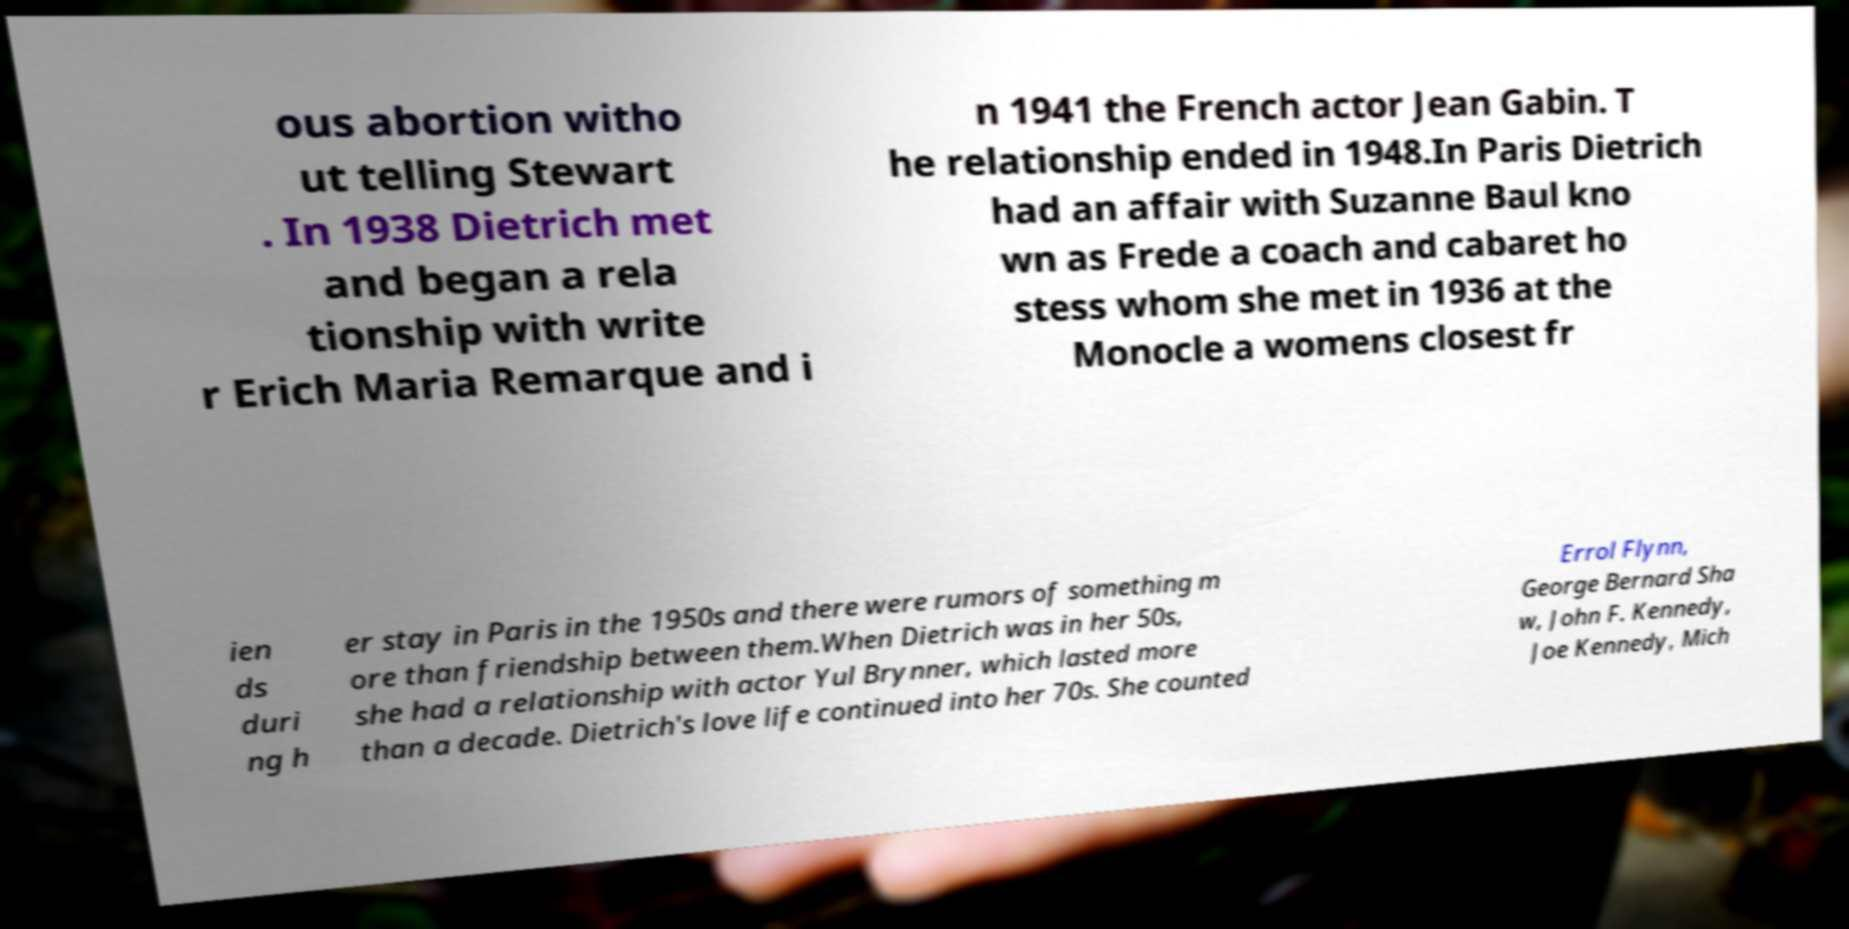Can you read and provide the text displayed in the image?This photo seems to have some interesting text. Can you extract and type it out for me? ous abortion witho ut telling Stewart . In 1938 Dietrich met and began a rela tionship with write r Erich Maria Remarque and i n 1941 the French actor Jean Gabin. T he relationship ended in 1948.In Paris Dietrich had an affair with Suzanne Baul kno wn as Frede a coach and cabaret ho stess whom she met in 1936 at the Monocle a womens closest fr ien ds duri ng h er stay in Paris in the 1950s and there were rumors of something m ore than friendship between them.When Dietrich was in her 50s, she had a relationship with actor Yul Brynner, which lasted more than a decade. Dietrich's love life continued into her 70s. She counted Errol Flynn, George Bernard Sha w, John F. Kennedy, Joe Kennedy, Mich 